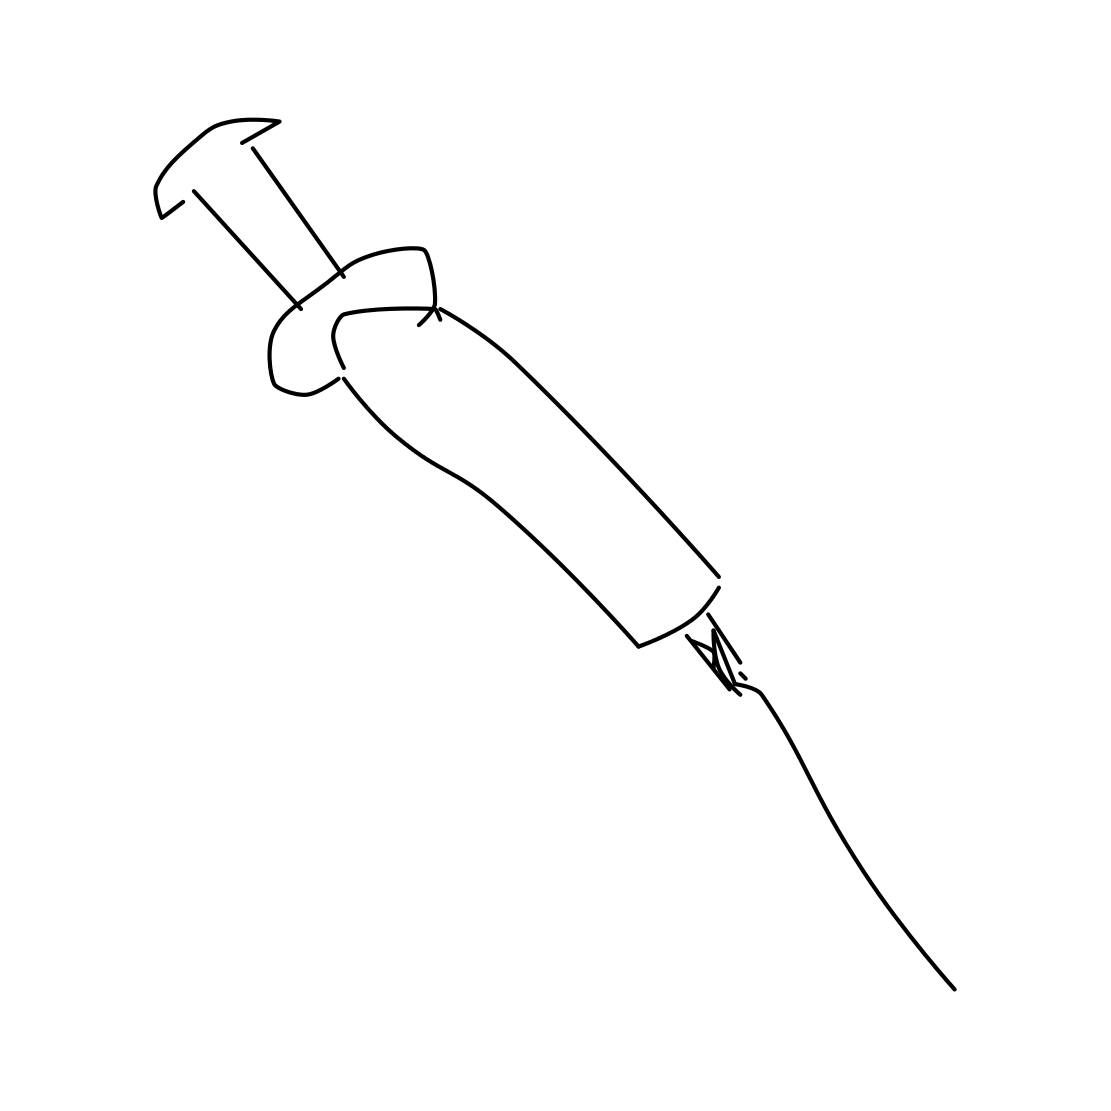Is the syringe meant for medical use? From the sketch, it's difficult to determine its intended use strictly from the image, as there are no clear indicators of medical or other specific usages. It's a basic representation and could be interpreted in various ways. 